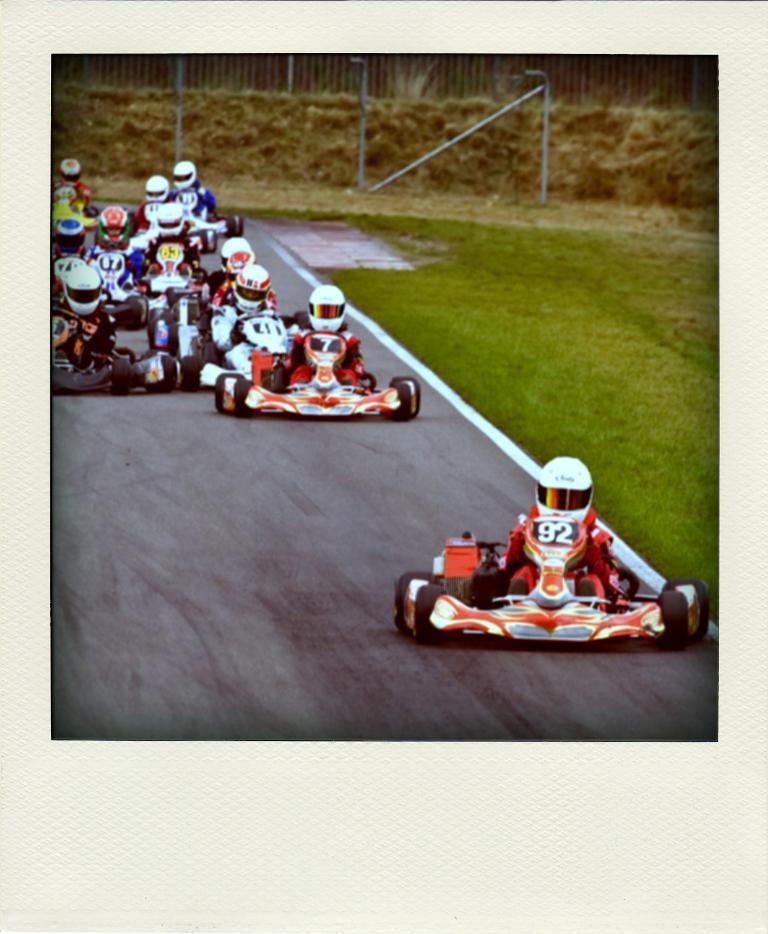What type of vehicles are on the road in the image? There are racing cars on the road in the image. What can be seen at the top of the image? There is a fencing at the top of the image. What color is the coil that is hanging from the balloon in the image? There is no coil or balloon present in the image. 